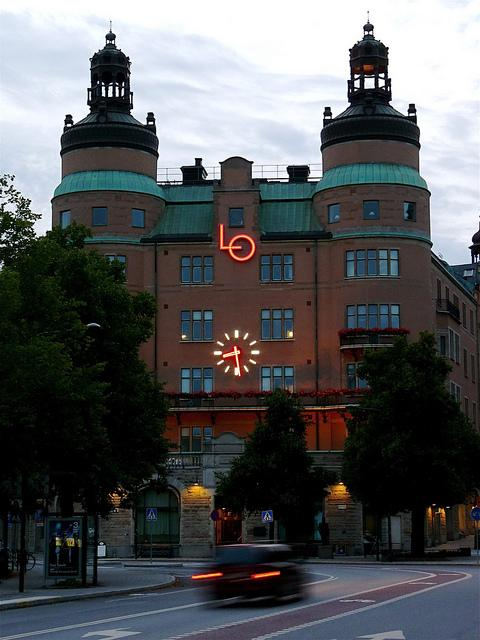What gas causes these lights to glow? Please explain your reasoning. neon. Lights that glow are caused by neon gas used with electricity. 